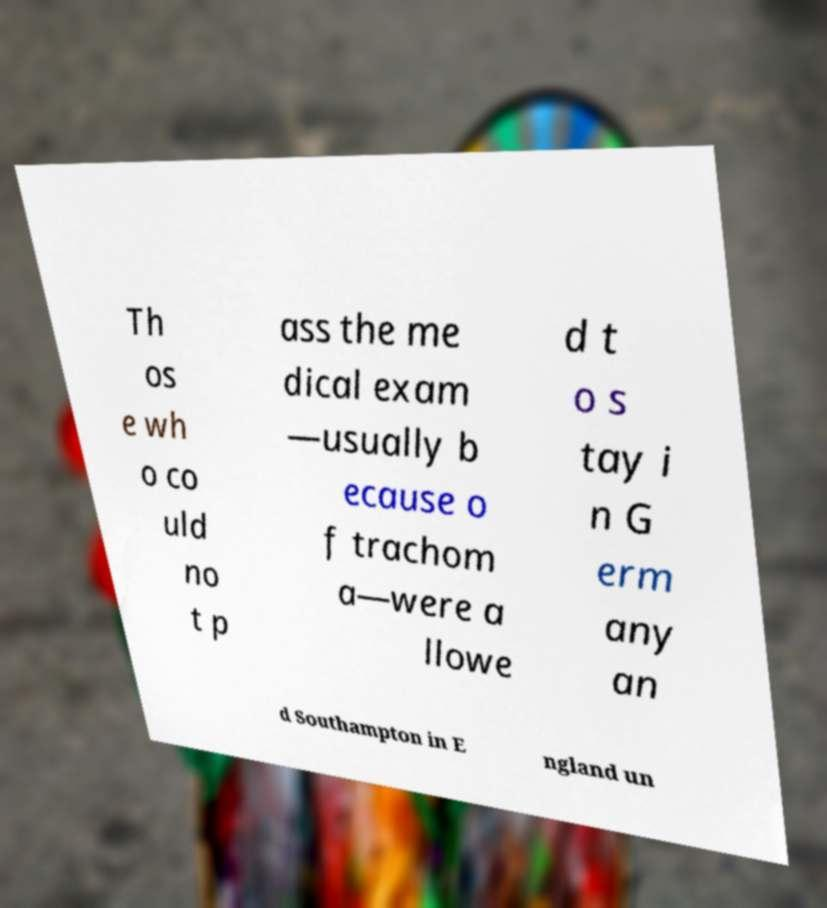Please read and relay the text visible in this image. What does it say? Th os e wh o co uld no t p ass the me dical exam —usually b ecause o f trachom a—were a llowe d t o s tay i n G erm any an d Southampton in E ngland un 